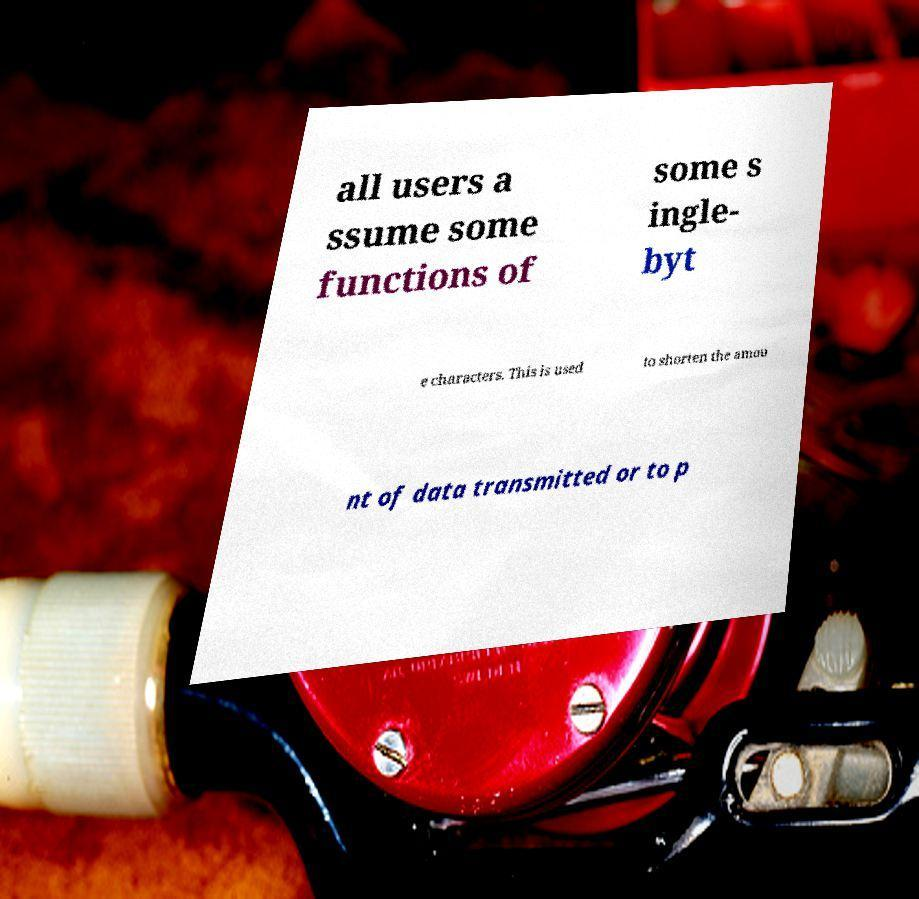Please read and relay the text visible in this image. What does it say? all users a ssume some functions of some s ingle- byt e characters. This is used to shorten the amou nt of data transmitted or to p 